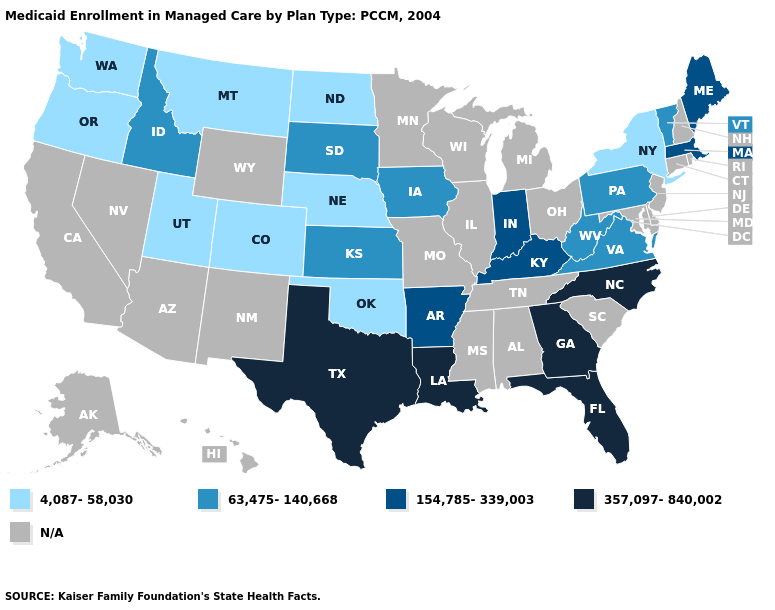Does Oklahoma have the lowest value in the South?
Answer briefly. Yes. Name the states that have a value in the range 357,097-840,002?
Give a very brief answer. Florida, Georgia, Louisiana, North Carolina, Texas. What is the value of South Dakota?
Concise answer only. 63,475-140,668. Name the states that have a value in the range 4,087-58,030?
Give a very brief answer. Colorado, Montana, Nebraska, New York, North Dakota, Oklahoma, Oregon, Utah, Washington. What is the value of Mississippi?
Give a very brief answer. N/A. Name the states that have a value in the range 63,475-140,668?
Keep it brief. Idaho, Iowa, Kansas, Pennsylvania, South Dakota, Vermont, Virginia, West Virginia. Does the first symbol in the legend represent the smallest category?
Concise answer only. Yes. Does the map have missing data?
Concise answer only. Yes. What is the lowest value in states that border California?
Give a very brief answer. 4,087-58,030. Name the states that have a value in the range 63,475-140,668?
Concise answer only. Idaho, Iowa, Kansas, Pennsylvania, South Dakota, Vermont, Virginia, West Virginia. Among the states that border South Carolina , which have the lowest value?
Short answer required. Georgia, North Carolina. Name the states that have a value in the range 63,475-140,668?
Write a very short answer. Idaho, Iowa, Kansas, Pennsylvania, South Dakota, Vermont, Virginia, West Virginia. Name the states that have a value in the range N/A?
Give a very brief answer. Alabama, Alaska, Arizona, California, Connecticut, Delaware, Hawaii, Illinois, Maryland, Michigan, Minnesota, Mississippi, Missouri, Nevada, New Hampshire, New Jersey, New Mexico, Ohio, Rhode Island, South Carolina, Tennessee, Wisconsin, Wyoming. What is the lowest value in the Northeast?
Keep it brief. 4,087-58,030. What is the value of Maryland?
Answer briefly. N/A. 